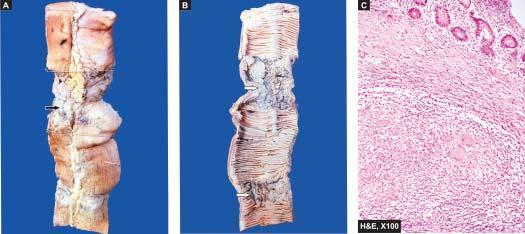does a few fibre cells and caudate cells show caseating epithelioid cell granulomas in the intestinal wall?
Answer the question using a single word or phrase. No 